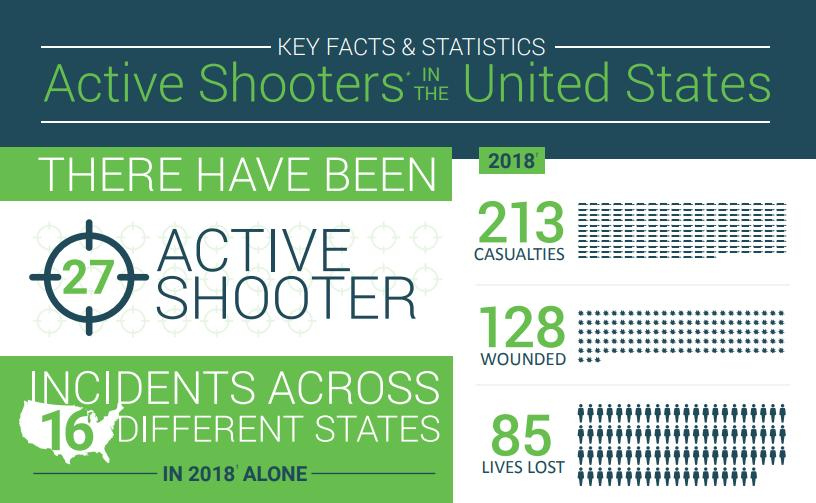Draw attention to some important aspects in this diagram. In 2018, a total of 213 casualties were observed across 16 different states in the U.S. In 2018, a total of 85 lives were lost across 16 different states in the United States. In 2018, a total of 128 individuals were wounded across 16 different states in the United States. In the year 2018, there were 27 active shooters in the United States. 